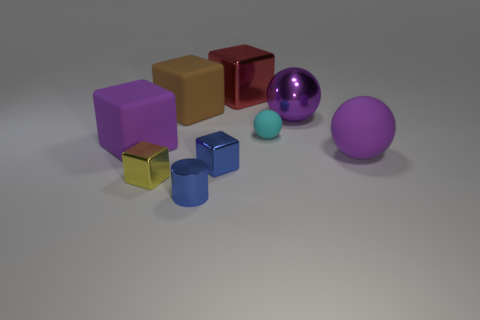Add 1 blue objects. How many objects exist? 10 Subtract all spheres. How many objects are left? 6 Subtract all small blue metal blocks. How many blocks are left? 4 Subtract all purple blocks. How many blocks are left? 4 Subtract 0 brown cylinders. How many objects are left? 9 Subtract 3 spheres. How many spheres are left? 0 Subtract all gray blocks. Subtract all cyan cylinders. How many blocks are left? 5 Subtract all gray cylinders. How many cyan balls are left? 1 Subtract all big brown things. Subtract all purple matte spheres. How many objects are left? 7 Add 5 large things. How many large things are left? 10 